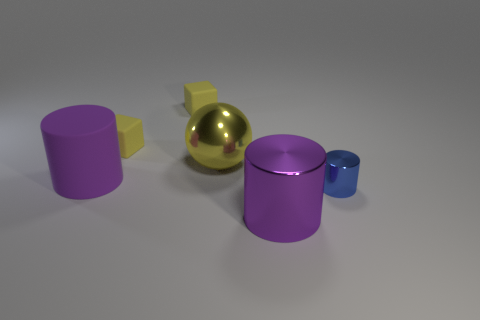What is the color of the shiny object that is the same size as the yellow metallic sphere?
Your answer should be compact. Purple. Does the yellow shiny thing have the same shape as the big purple thing to the right of the sphere?
Your answer should be compact. No. There is a large metallic object that is the same color as the matte cylinder; what shape is it?
Make the answer very short. Cylinder. What number of things are in front of the large shiny thing on the left side of the big cylinder on the right side of the big purple matte object?
Keep it short and to the point. 3. What size is the purple cylinder behind the shiny thing in front of the blue metal thing?
Provide a succinct answer. Large. What size is the blue thing that is made of the same material as the big yellow sphere?
Offer a terse response. Small. What shape is the thing that is on the left side of the tiny blue shiny object and in front of the purple rubber object?
Make the answer very short. Cylinder. Is the number of rubber cylinders behind the large purple matte thing the same as the number of tiny brown cylinders?
Provide a succinct answer. Yes. What number of objects are purple metal cylinders or big purple things that are in front of the blue object?
Your response must be concise. 1. Is there a large metallic object that has the same shape as the tiny metallic object?
Ensure brevity in your answer.  Yes. 